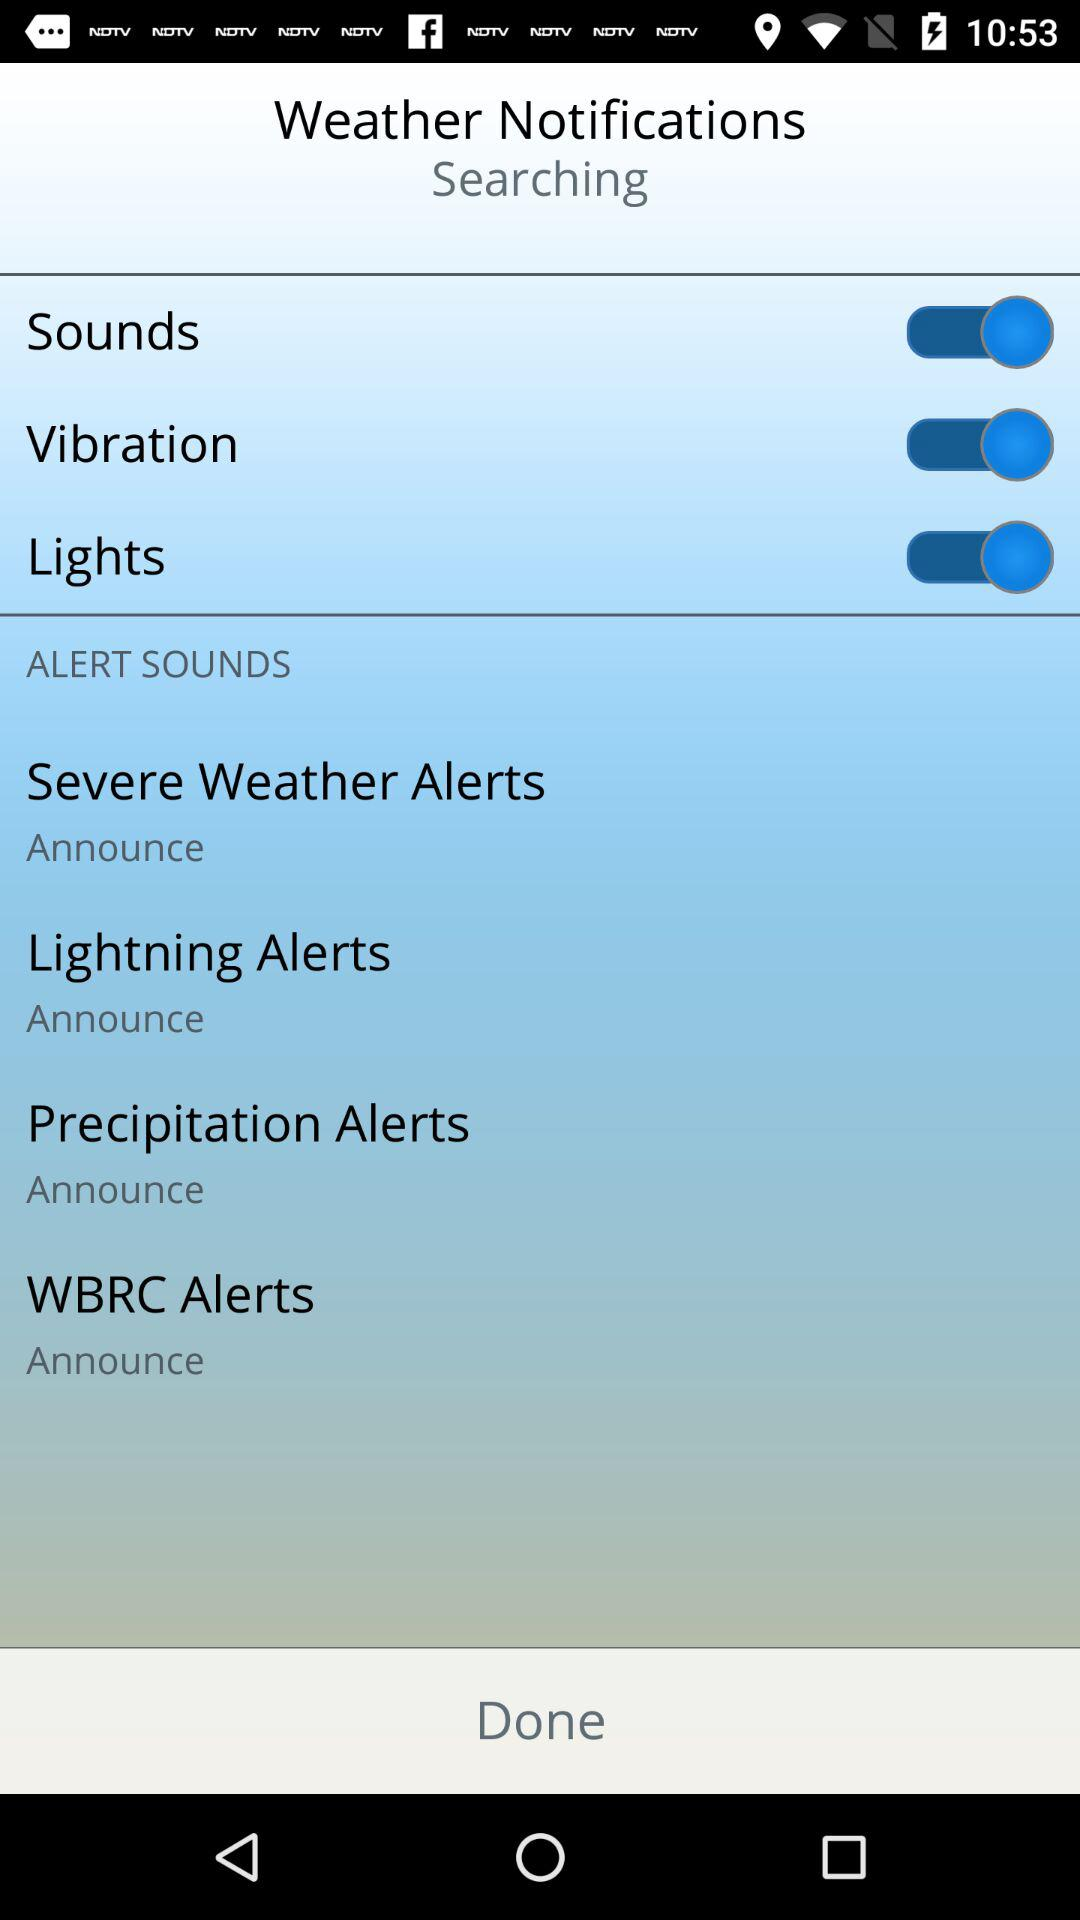How many alerts have an announce switch?
Answer the question using a single word or phrase. 4 